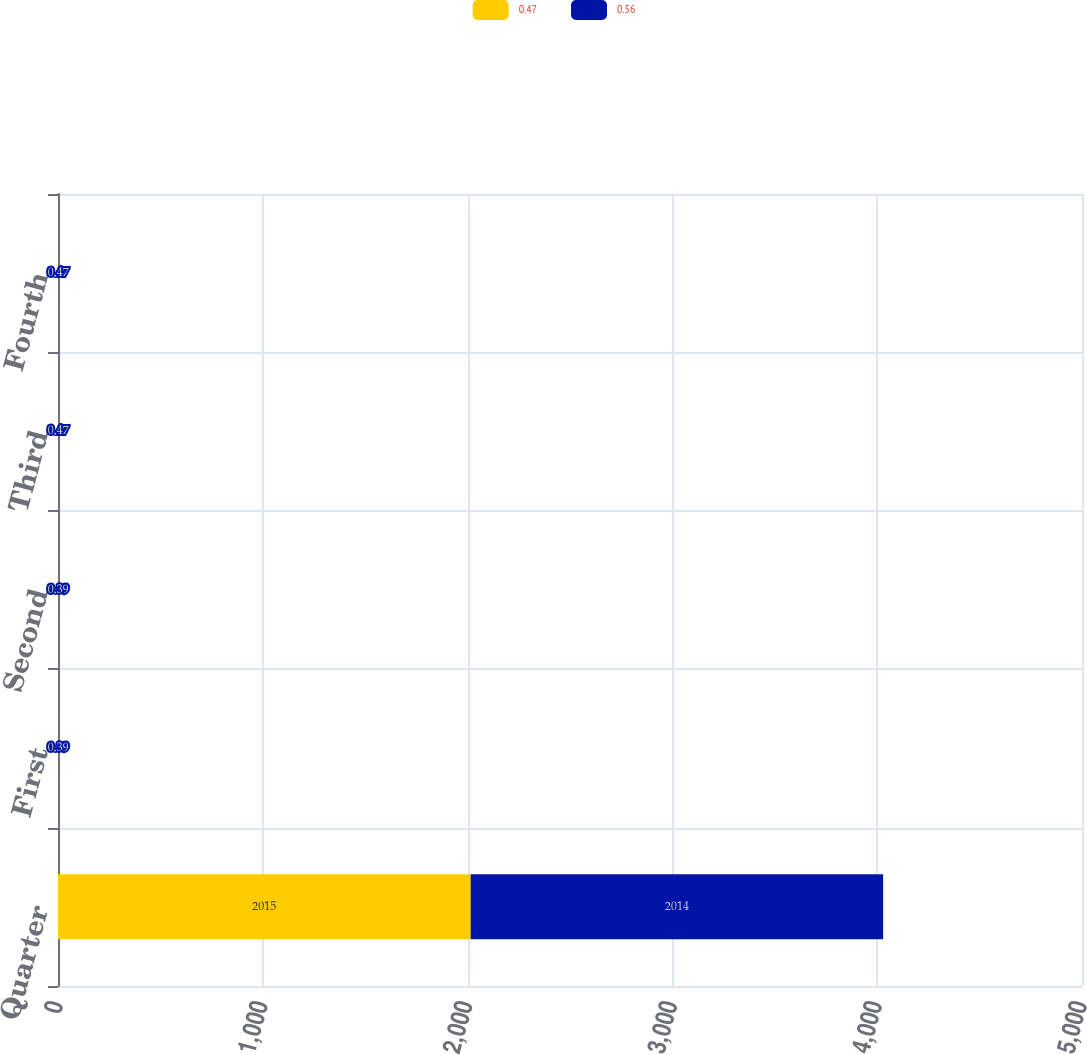Convert chart to OTSL. <chart><loc_0><loc_0><loc_500><loc_500><stacked_bar_chart><ecel><fcel>Quarter<fcel>First<fcel>Second<fcel>Third<fcel>Fourth<nl><fcel>0.47<fcel>2015<fcel>0.47<fcel>0.47<fcel>0.56<fcel>0.56<nl><fcel>0.56<fcel>2014<fcel>0.39<fcel>0.39<fcel>0.47<fcel>0.47<nl></chart> 